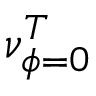Convert formula to latex. <formula><loc_0><loc_0><loc_500><loc_500>\nu _ { \phi = 0 } ^ { T }</formula> 